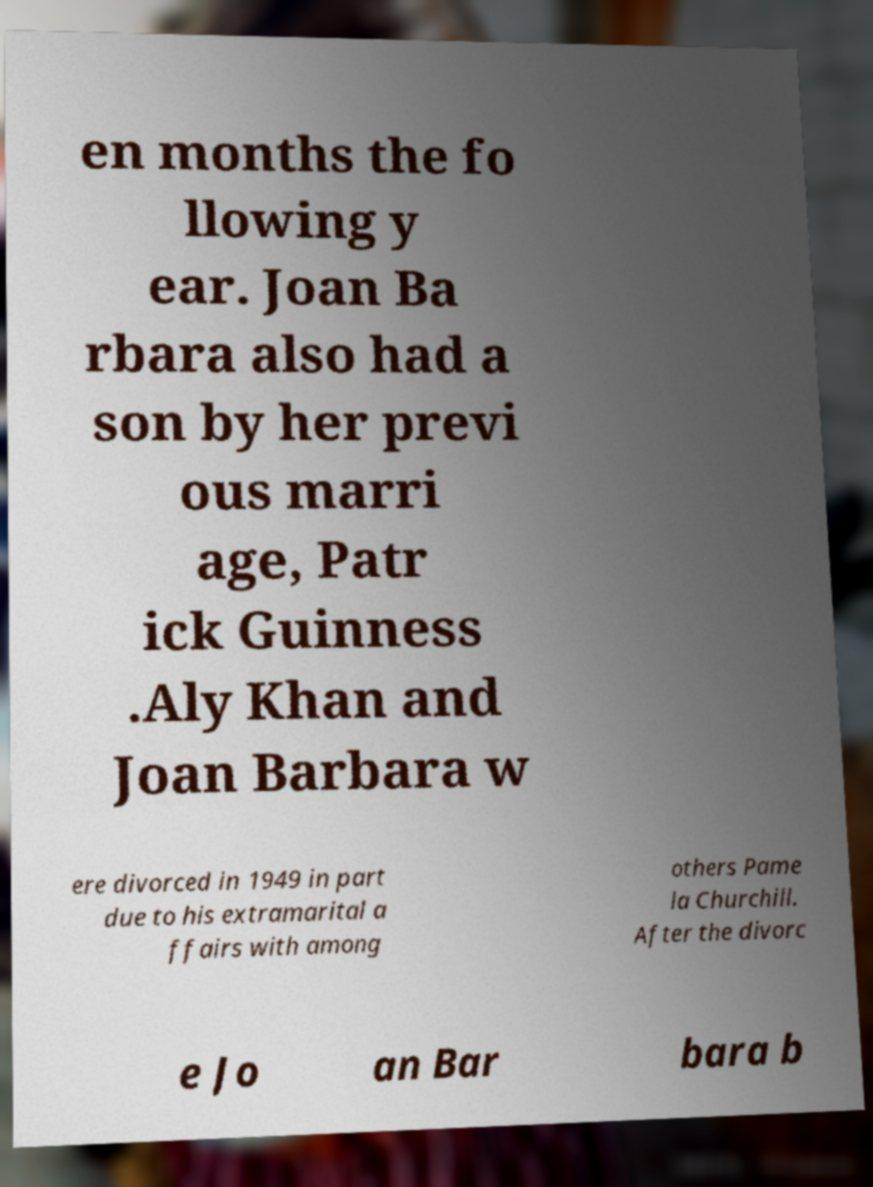Can you accurately transcribe the text from the provided image for me? en months the fo llowing y ear. Joan Ba rbara also had a son by her previ ous marri age, Patr ick Guinness .Aly Khan and Joan Barbara w ere divorced in 1949 in part due to his extramarital a ffairs with among others Pame la Churchill. After the divorc e Jo an Bar bara b 